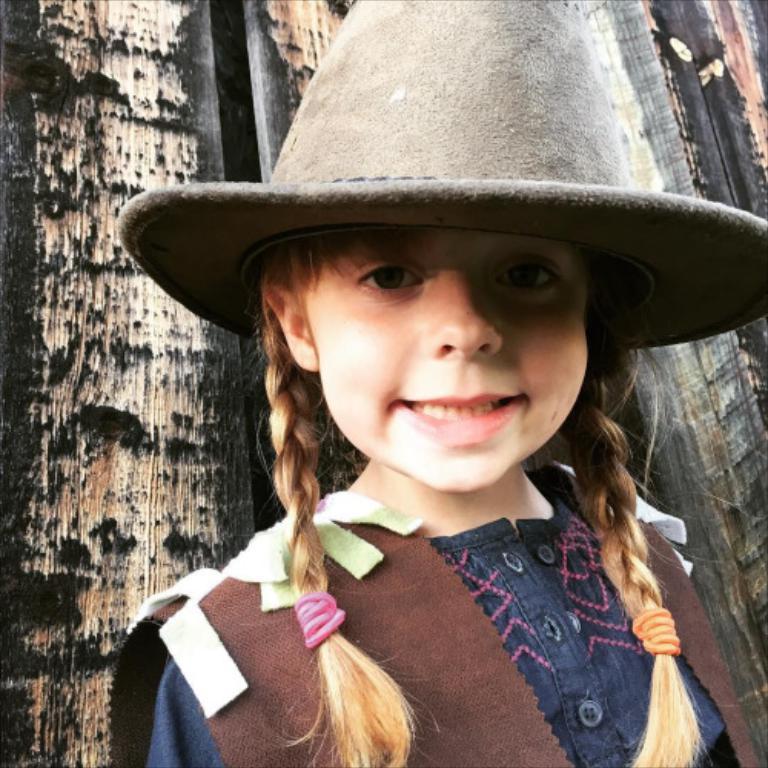Can you describe this image briefly? In this image in front there is a girl wearing a hat. Behind her there is a wooden wall. 